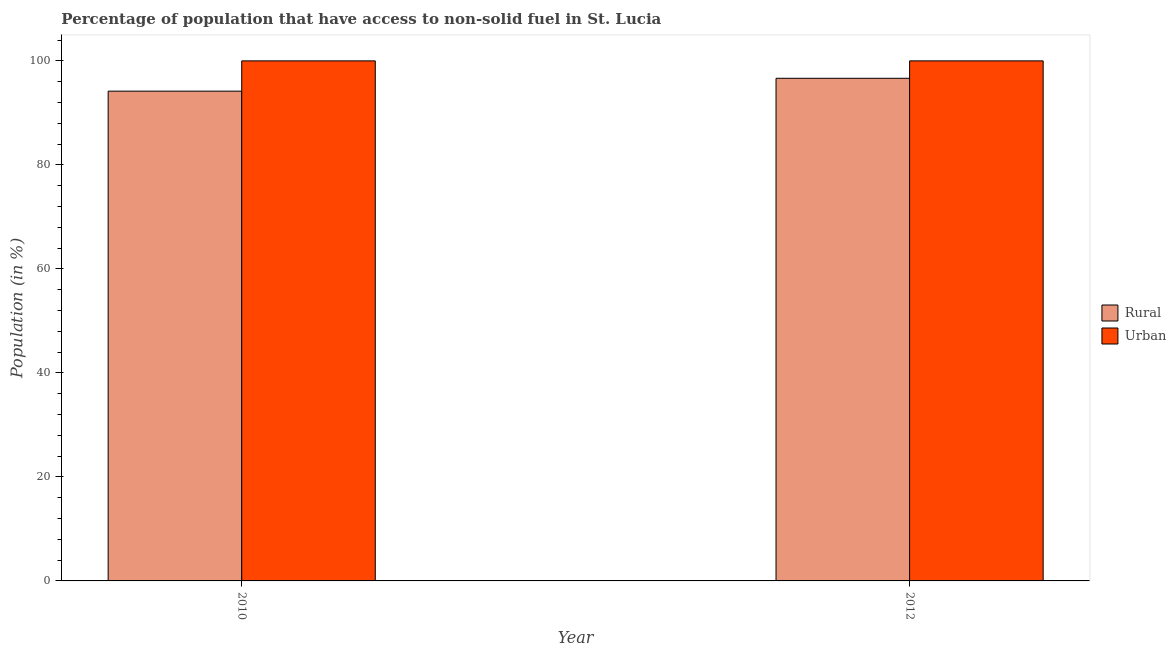How many groups of bars are there?
Offer a very short reply. 2. What is the label of the 2nd group of bars from the left?
Offer a terse response. 2012. What is the urban population in 2012?
Your response must be concise. 100. Across all years, what is the maximum rural population?
Make the answer very short. 96.65. Across all years, what is the minimum urban population?
Keep it short and to the point. 100. In which year was the rural population maximum?
Keep it short and to the point. 2012. What is the total rural population in the graph?
Offer a terse response. 190.83. What is the difference between the rural population in 2010 and that in 2012?
Your answer should be very brief. -2.47. What is the difference between the rural population in 2012 and the urban population in 2010?
Your response must be concise. 2.47. What is the average rural population per year?
Give a very brief answer. 95.42. In the year 2012, what is the difference between the urban population and rural population?
Your answer should be compact. 0. What is the ratio of the rural population in 2010 to that in 2012?
Offer a very short reply. 0.97. What does the 2nd bar from the left in 2012 represents?
Your answer should be compact. Urban. What does the 2nd bar from the right in 2010 represents?
Provide a short and direct response. Rural. How many bars are there?
Provide a short and direct response. 4. What is the difference between two consecutive major ticks on the Y-axis?
Keep it short and to the point. 20. Does the graph contain any zero values?
Offer a terse response. No. How are the legend labels stacked?
Provide a succinct answer. Vertical. What is the title of the graph?
Keep it short and to the point. Percentage of population that have access to non-solid fuel in St. Lucia. What is the label or title of the X-axis?
Offer a very short reply. Year. What is the label or title of the Y-axis?
Ensure brevity in your answer.  Population (in %). What is the Population (in %) of Rural in 2010?
Provide a succinct answer. 94.18. What is the Population (in %) of Urban in 2010?
Offer a very short reply. 100. What is the Population (in %) in Rural in 2012?
Your answer should be very brief. 96.65. Across all years, what is the maximum Population (in %) in Rural?
Your response must be concise. 96.65. Across all years, what is the minimum Population (in %) of Rural?
Make the answer very short. 94.18. What is the total Population (in %) of Rural in the graph?
Your answer should be very brief. 190.83. What is the total Population (in %) in Urban in the graph?
Provide a short and direct response. 200. What is the difference between the Population (in %) of Rural in 2010 and that in 2012?
Make the answer very short. -2.47. What is the difference between the Population (in %) in Urban in 2010 and that in 2012?
Give a very brief answer. 0. What is the difference between the Population (in %) in Rural in 2010 and the Population (in %) in Urban in 2012?
Make the answer very short. -5.82. What is the average Population (in %) in Rural per year?
Provide a succinct answer. 95.42. In the year 2010, what is the difference between the Population (in %) of Rural and Population (in %) of Urban?
Your answer should be compact. -5.82. In the year 2012, what is the difference between the Population (in %) in Rural and Population (in %) in Urban?
Give a very brief answer. -3.35. What is the ratio of the Population (in %) of Rural in 2010 to that in 2012?
Make the answer very short. 0.97. What is the ratio of the Population (in %) of Urban in 2010 to that in 2012?
Ensure brevity in your answer.  1. What is the difference between the highest and the second highest Population (in %) of Rural?
Your response must be concise. 2.47. What is the difference between the highest and the second highest Population (in %) of Urban?
Provide a short and direct response. 0. What is the difference between the highest and the lowest Population (in %) of Rural?
Ensure brevity in your answer.  2.47. 